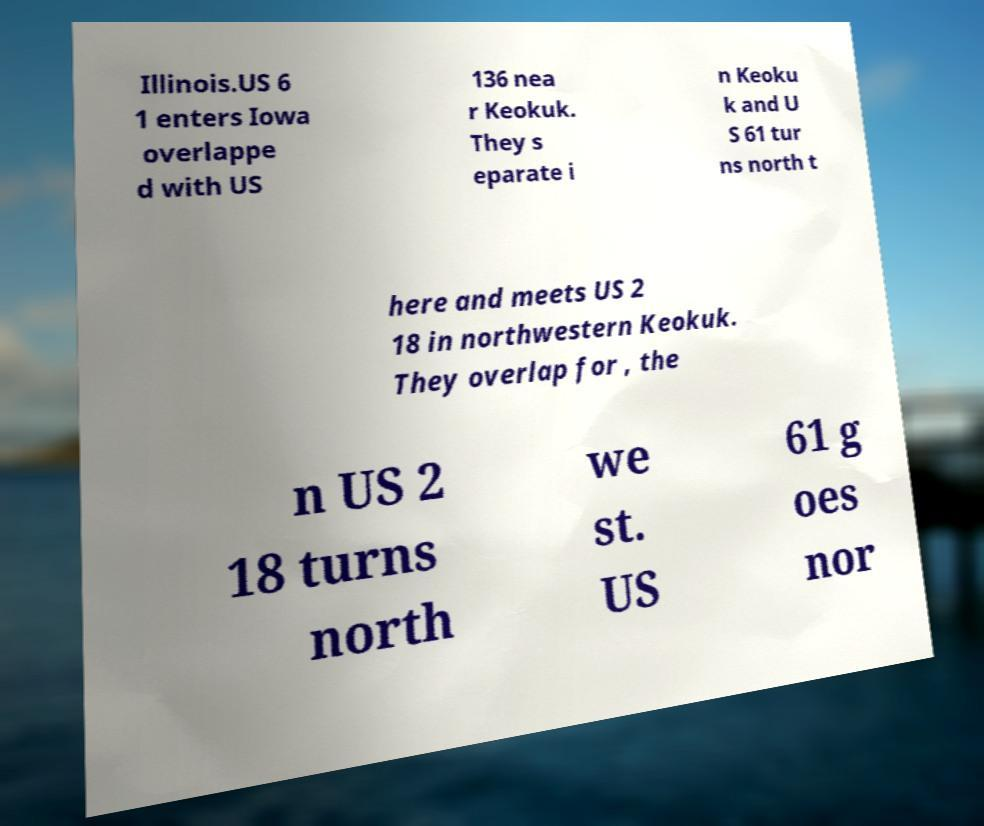There's text embedded in this image that I need extracted. Can you transcribe it verbatim? Illinois.US 6 1 enters Iowa overlappe d with US 136 nea r Keokuk. They s eparate i n Keoku k and U S 61 tur ns north t here and meets US 2 18 in northwestern Keokuk. They overlap for , the n US 2 18 turns north we st. US 61 g oes nor 